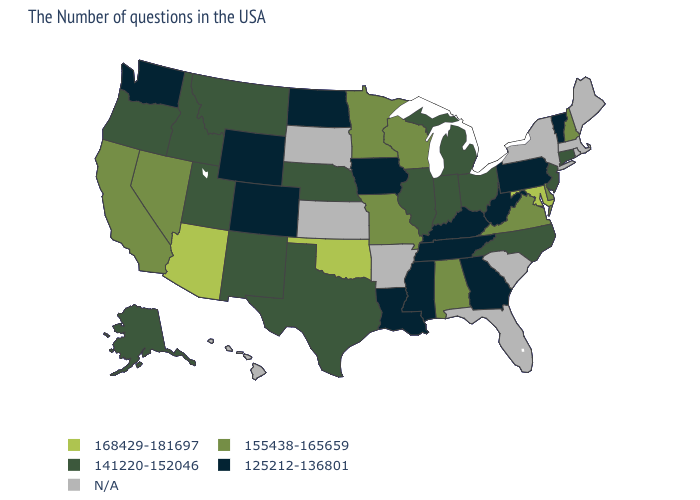What is the value of New Mexico?
Quick response, please. 141220-152046. Name the states that have a value in the range 125212-136801?
Answer briefly. Vermont, Pennsylvania, West Virginia, Georgia, Kentucky, Tennessee, Mississippi, Louisiana, Iowa, North Dakota, Wyoming, Colorado, Washington. What is the lowest value in states that border South Carolina?
Give a very brief answer. 125212-136801. Is the legend a continuous bar?
Write a very short answer. No. What is the highest value in the Northeast ?
Give a very brief answer. 155438-165659. Name the states that have a value in the range N/A?
Answer briefly. Maine, Massachusetts, Rhode Island, New York, South Carolina, Florida, Arkansas, Kansas, South Dakota, Hawaii. Name the states that have a value in the range 125212-136801?
Give a very brief answer. Vermont, Pennsylvania, West Virginia, Georgia, Kentucky, Tennessee, Mississippi, Louisiana, Iowa, North Dakota, Wyoming, Colorado, Washington. Name the states that have a value in the range N/A?
Be succinct. Maine, Massachusetts, Rhode Island, New York, South Carolina, Florida, Arkansas, Kansas, South Dakota, Hawaii. Name the states that have a value in the range N/A?
Keep it brief. Maine, Massachusetts, Rhode Island, New York, South Carolina, Florida, Arkansas, Kansas, South Dakota, Hawaii. What is the highest value in states that border South Carolina?
Concise answer only. 141220-152046. What is the value of Connecticut?
Be succinct. 141220-152046. Does the first symbol in the legend represent the smallest category?
Short answer required. No. What is the value of Missouri?
Write a very short answer. 155438-165659. What is the value of Montana?
Short answer required. 141220-152046. Name the states that have a value in the range 168429-181697?
Answer briefly. Maryland, Oklahoma, Arizona. 